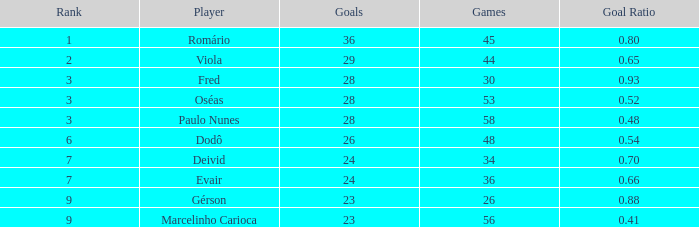How many games have 23 goals with a rank greater than 9? 0.0. 